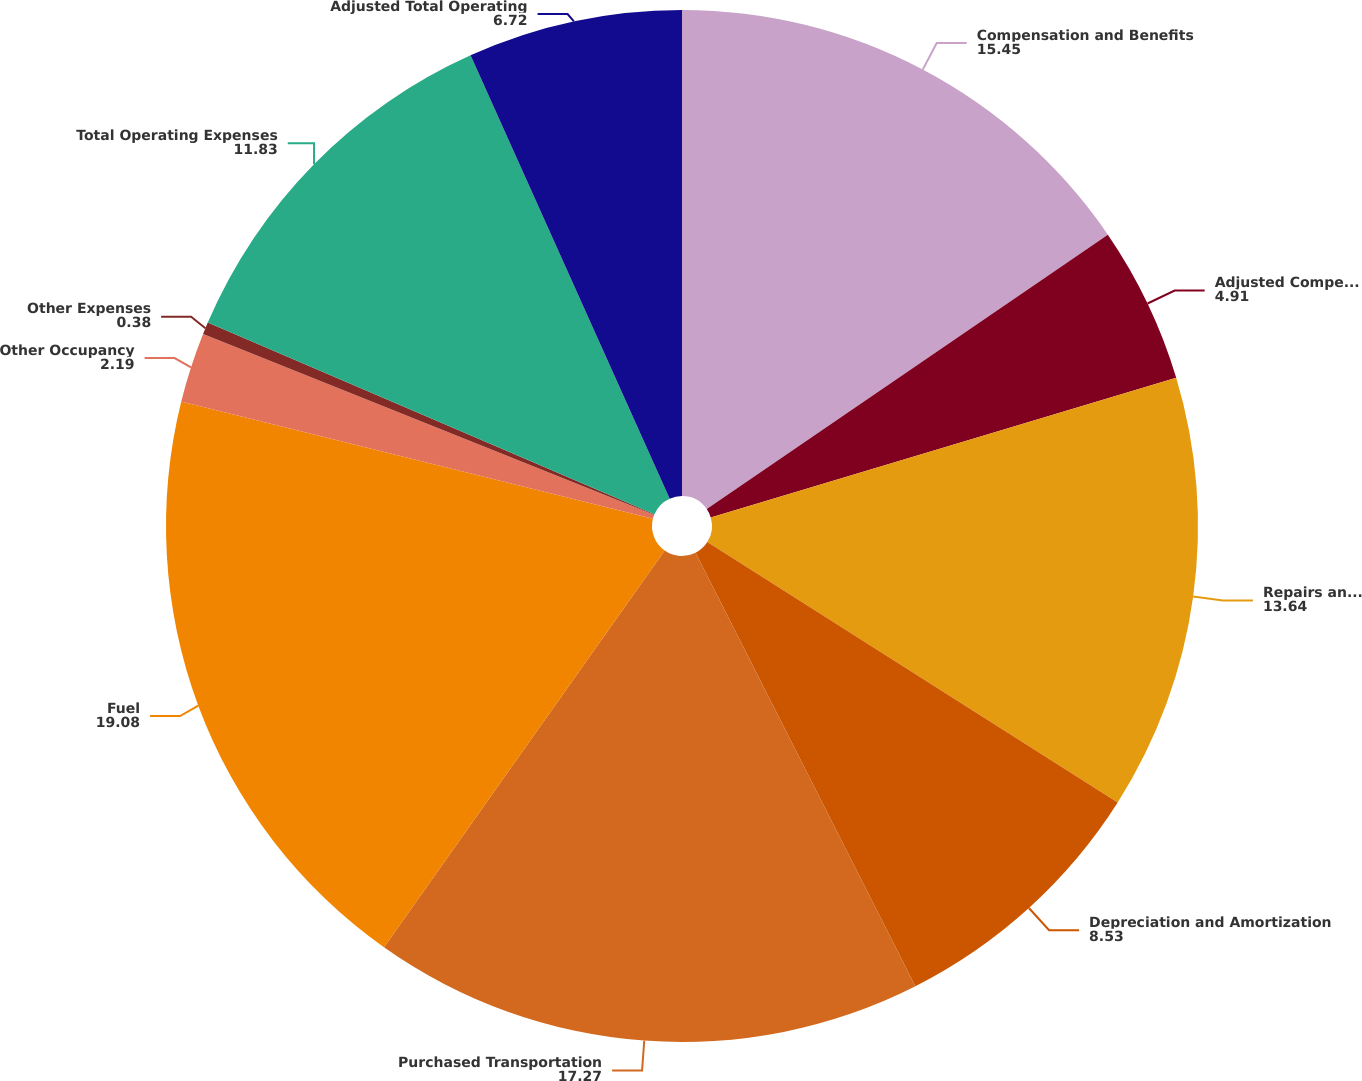Convert chart to OTSL. <chart><loc_0><loc_0><loc_500><loc_500><pie_chart><fcel>Compensation and Benefits<fcel>Adjusted Compensation and<fcel>Repairs and Maintenance<fcel>Depreciation and Amortization<fcel>Purchased Transportation<fcel>Fuel<fcel>Other Occupancy<fcel>Other Expenses<fcel>Total Operating Expenses<fcel>Adjusted Total Operating<nl><fcel>15.45%<fcel>4.91%<fcel>13.64%<fcel>8.53%<fcel>17.27%<fcel>19.08%<fcel>2.19%<fcel>0.38%<fcel>11.83%<fcel>6.72%<nl></chart> 